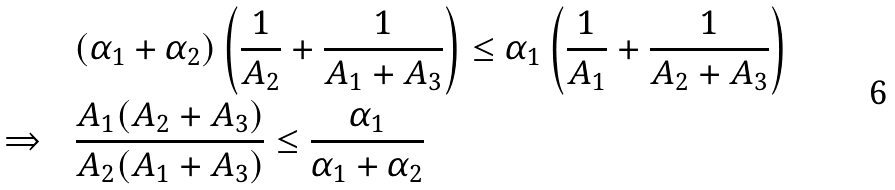<formula> <loc_0><loc_0><loc_500><loc_500>& ( \alpha _ { 1 } + \alpha _ { 2 } ) \left ( \frac { 1 } { A _ { 2 } } + \frac { 1 } { A _ { 1 } + A _ { 3 } } \right ) \leq \alpha _ { 1 } \left ( \frac { 1 } { A _ { 1 } } + \frac { 1 } { A _ { 2 } + A _ { 3 } } \right ) \\ \Rightarrow \quad & \frac { A _ { 1 } ( A _ { 2 } + A _ { 3 } ) } { A _ { 2 } ( A _ { 1 } + A _ { 3 } ) } \leq \frac { \alpha _ { 1 } } { \alpha _ { 1 } + \alpha _ { 2 } }</formula> 